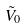<formula> <loc_0><loc_0><loc_500><loc_500>\tilde { V } _ { 0 }</formula> 